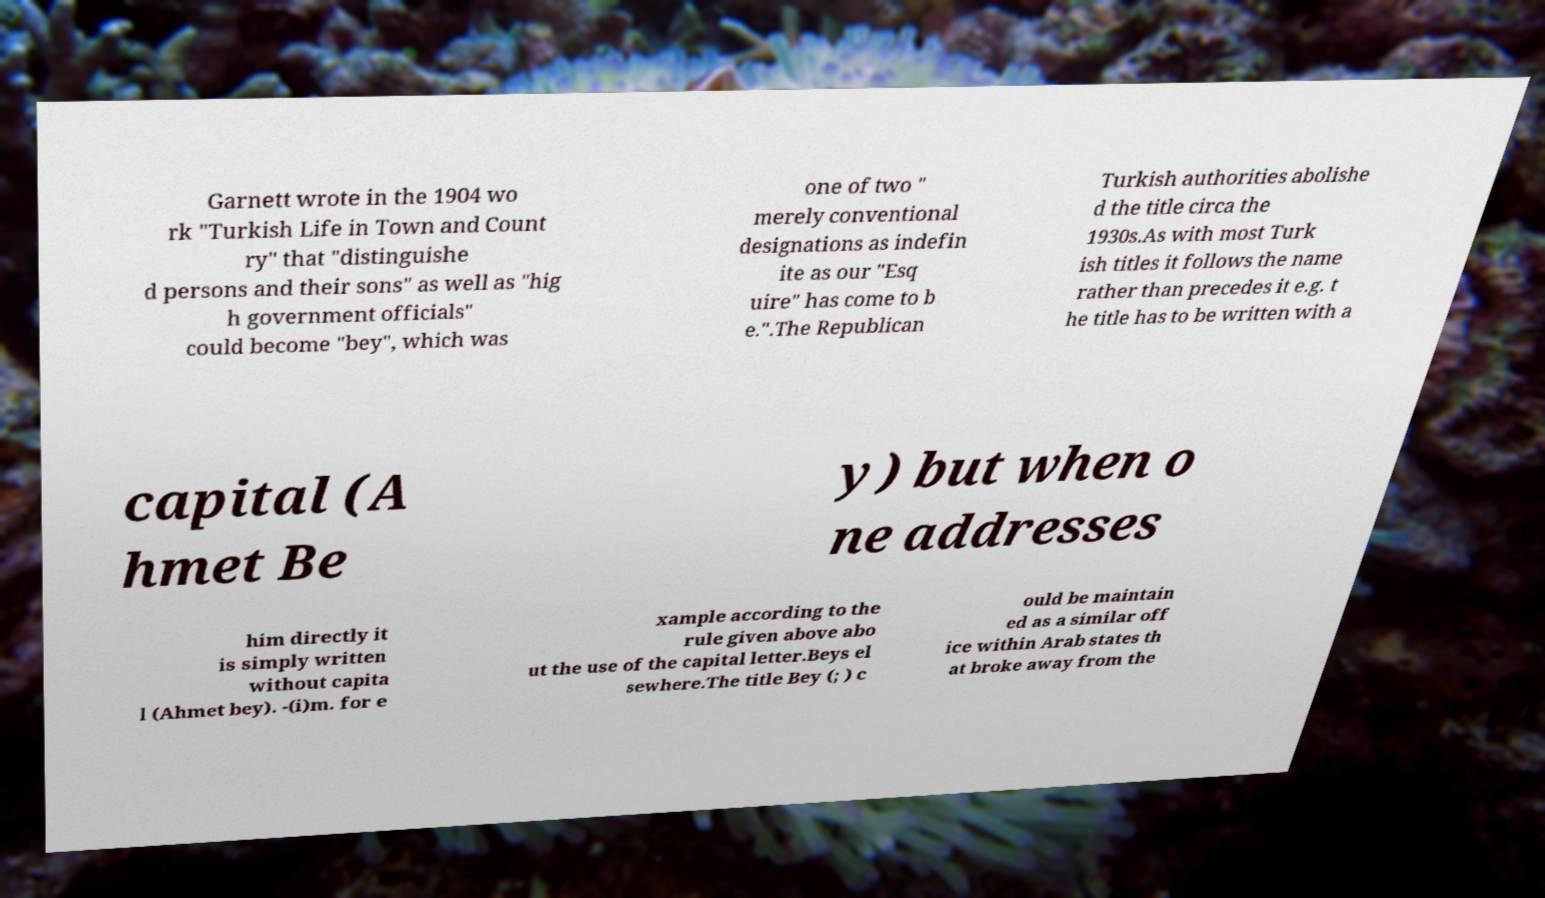Can you read and provide the text displayed in the image?This photo seems to have some interesting text. Can you extract and type it out for me? Garnett wrote in the 1904 wo rk "Turkish Life in Town and Count ry" that "distinguishe d persons and their sons" as well as "hig h government officials" could become "bey", which was one of two " merely conventional designations as indefin ite as our "Esq uire" has come to b e.".The Republican Turkish authorities abolishe d the title circa the 1930s.As with most Turk ish titles it follows the name rather than precedes it e.g. t he title has to be written with a capital (A hmet Be y) but when o ne addresses him directly it is simply written without capita l (Ahmet bey). -(i)m. for e xample according to the rule given above abo ut the use of the capital letter.Beys el sewhere.The title Bey (; ) c ould be maintain ed as a similar off ice within Arab states th at broke away from the 